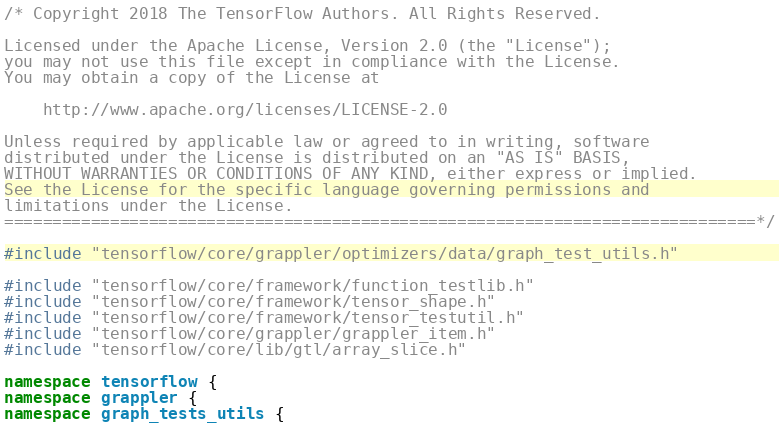Convert code to text. <code><loc_0><loc_0><loc_500><loc_500><_C++_>/* Copyright 2018 The TensorFlow Authors. All Rights Reserved.

Licensed under the Apache License, Version 2.0 (the "License");
you may not use this file except in compliance with the License.
You may obtain a copy of the License at

    http://www.apache.org/licenses/LICENSE-2.0

Unless required by applicable law or agreed to in writing, software
distributed under the License is distributed on an "AS IS" BASIS,
WITHOUT WARRANTIES OR CONDITIONS OF ANY KIND, either express or implied.
See the License for the specific language governing permissions and
limitations under the License.
==============================================================================*/

#include "tensorflow/core/grappler/optimizers/data/graph_test_utils.h"

#include "tensorflow/core/framework/function_testlib.h"
#include "tensorflow/core/framework/tensor_shape.h"
#include "tensorflow/core/framework/tensor_testutil.h"
#include "tensorflow/core/grappler/grappler_item.h"
#include "tensorflow/core/lib/gtl/array_slice.h"

namespace tensorflow {
namespace grappler {
namespace graph_tests_utils {
</code> 